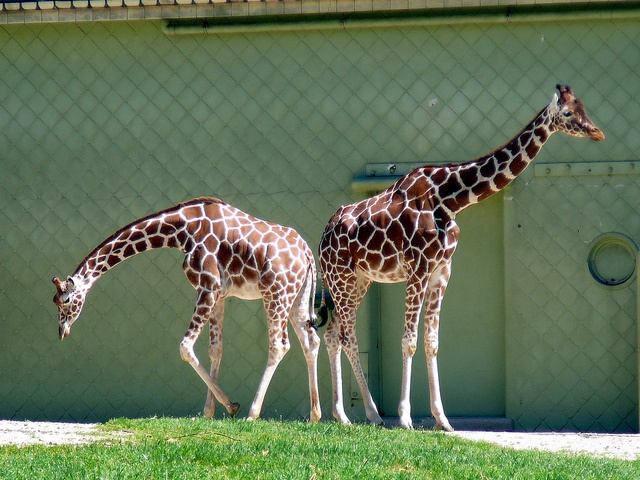Describe the objects in this image and their specific colors. I can see giraffe in black, gray, maroon, and darkgray tones and giraffe in black, gray, white, and darkgray tones in this image. 